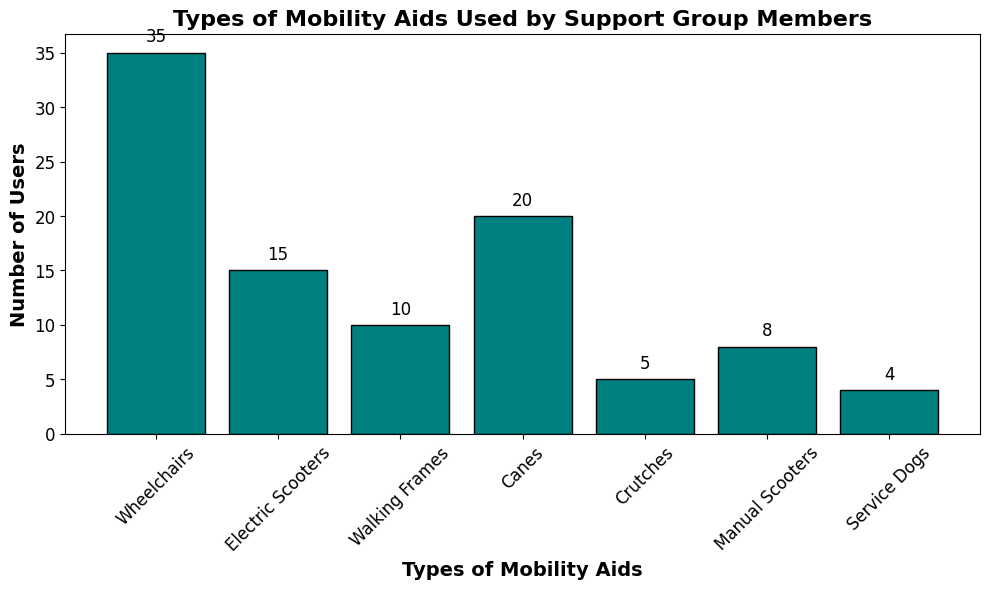How many more wheelchair users are there compared to crutches users? The number of wheelchair users is 35, and the number of crutches users is 5. Subtract the count of crutches users from wheelchair users: 35 - 5. The difference is 30.
Answer: 30 Which mobility aid is used by the fewest support group members? Look at the heights of the bars and find the shortest. The shortest bar corresponds to Service Dogs, which is used by 4 members.
Answer: Service Dogs What is the total number of users who use either walking frames or canes? The count for walking frames is 10, and the count for canes is 20. Add these two counts: 10 + 20. The sum is 30.
Answer: 30 Which mobility aid category is the second most used among the support group members? First, identify the mobility aid with the highest count, which is Wheelchairs (35). The second-highest count is Canes, with 20 users.
Answer: Canes How many support group members are there in total? Sum the counts of all mobility aids: 35 (Wheelchairs) + 15 (Electric Scooters) + 10 (Walking Frames) + 20 (Canes) + 5 (Crutches) + 8 (Manual Scooters) + 4 (Service Dogs). The total is 97.
Answer: 97 What is the difference in the number of users between Electric Scooters and Manual Scooters? The count for electric scooters is 15, and the count for manual scooters is 8. Subtract the count of manual scooters from electric scooters: 15 - 8. The difference is 7.
Answer: 7 Do more people use electric scooters or crutches? Compare the heights of the bars for Electric Scooters and Crutches. The count for Electric Scooters is 15, and the count for Crutches is 5. Since 15 > 5, more people use electric scooters.
Answer: Electric Scooters What is the average number of users per mobility aid category? There are 7 categories, and the total number of users is 97. Divide the total number of users by the number of categories: 97 / 7. The average is approximately 13.86.
Answer: 13.86 